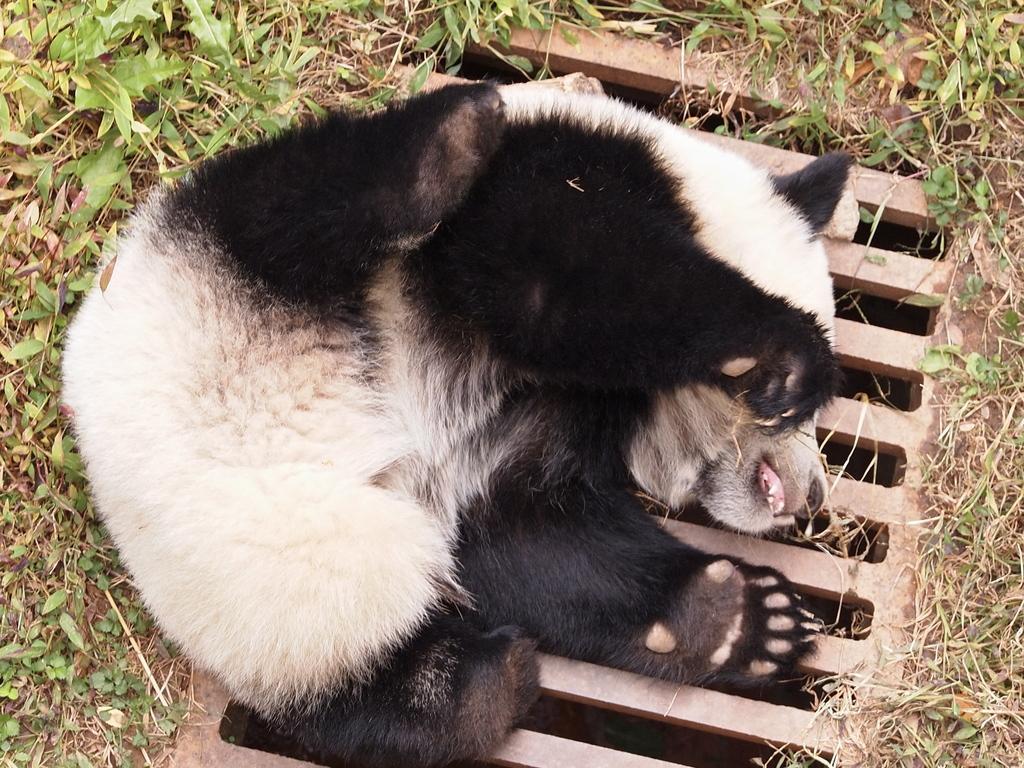Could you give a brief overview of what you see in this image? In this image I can see an animal which is black and cream in color is on the ground. I can see the manhole grill below it. I can see few trees and some grass on the ground. 